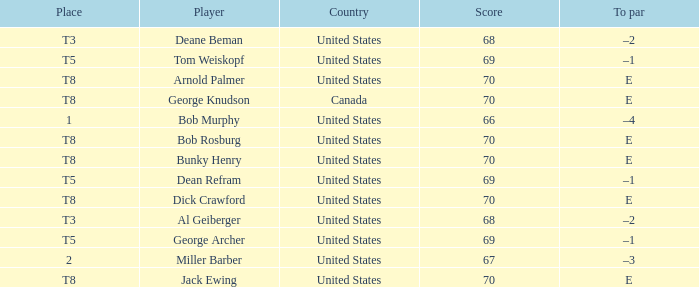Where did Bob Murphy of the United States place? 1.0. Would you be able to parse every entry in this table? {'header': ['Place', 'Player', 'Country', 'Score', 'To par'], 'rows': [['T3', 'Deane Beman', 'United States', '68', '–2'], ['T5', 'Tom Weiskopf', 'United States', '69', '–1'], ['T8', 'Arnold Palmer', 'United States', '70', 'E'], ['T8', 'George Knudson', 'Canada', '70', 'E'], ['1', 'Bob Murphy', 'United States', '66', '–4'], ['T8', 'Bob Rosburg', 'United States', '70', 'E'], ['T8', 'Bunky Henry', 'United States', '70', 'E'], ['T5', 'Dean Refram', 'United States', '69', '–1'], ['T8', 'Dick Crawford', 'United States', '70', 'E'], ['T3', 'Al Geiberger', 'United States', '68', '–2'], ['T5', 'George Archer', 'United States', '69', '–1'], ['2', 'Miller Barber', 'United States', '67', '–3'], ['T8', 'Jack Ewing', 'United States', '70', 'E']]} 